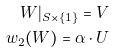Convert formula to latex. <formula><loc_0><loc_0><loc_500><loc_500>W | _ { S \times \{ 1 \} } = V \\ w _ { 2 } ( W ) = \alpha \cdot U</formula> 